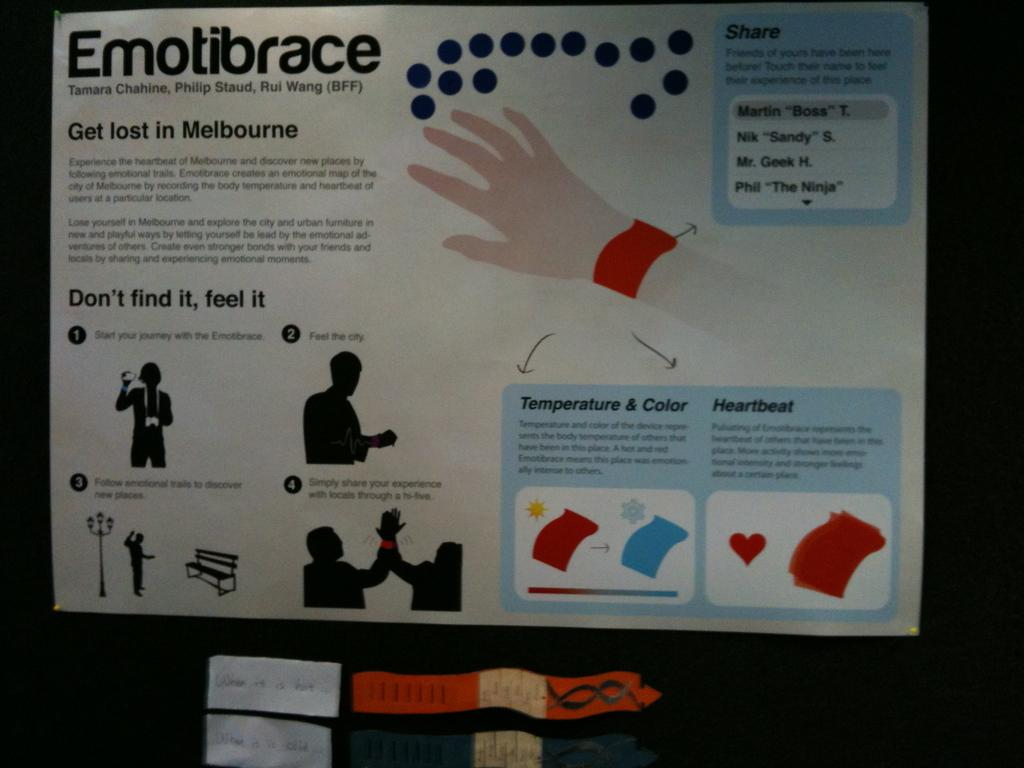<image>
Offer a succinct explanation of the picture presented. Instructions for emotibrace showing people "Don't find it, feel it". 